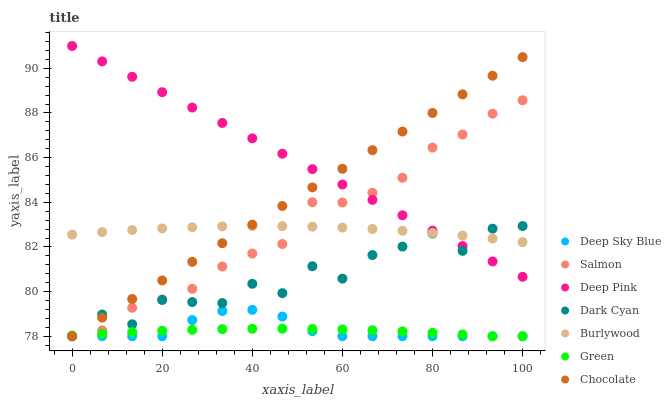Does Green have the minimum area under the curve?
Answer yes or no. Yes. Does Deep Pink have the maximum area under the curve?
Answer yes or no. Yes. Does Burlywood have the minimum area under the curve?
Answer yes or no. No. Does Burlywood have the maximum area under the curve?
Answer yes or no. No. Is Deep Pink the smoothest?
Answer yes or no. Yes. Is Dark Cyan the roughest?
Answer yes or no. Yes. Is Burlywood the smoothest?
Answer yes or no. No. Is Burlywood the roughest?
Answer yes or no. No. Does Salmon have the lowest value?
Answer yes or no. Yes. Does Burlywood have the lowest value?
Answer yes or no. No. Does Deep Pink have the highest value?
Answer yes or no. Yes. Does Burlywood have the highest value?
Answer yes or no. No. Is Deep Sky Blue less than Deep Pink?
Answer yes or no. Yes. Is Deep Pink greater than Deep Sky Blue?
Answer yes or no. Yes. Does Deep Sky Blue intersect Dark Cyan?
Answer yes or no. Yes. Is Deep Sky Blue less than Dark Cyan?
Answer yes or no. No. Is Deep Sky Blue greater than Dark Cyan?
Answer yes or no. No. Does Deep Sky Blue intersect Deep Pink?
Answer yes or no. No. 